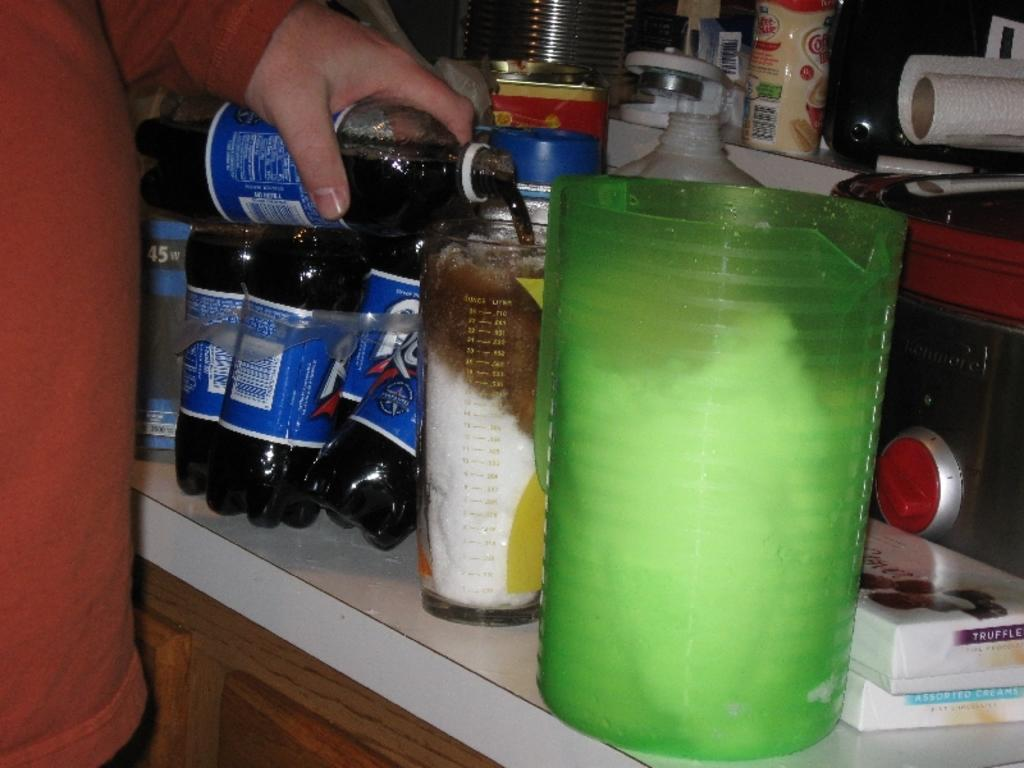What type of objects can be seen on the countertop in the image? There are bottles, a glass, and containers on the countertop in the image. What is the person in the image doing with one of the bottles? One person is holding a bottle in the image. Can you describe the other objects on the countertop? The other objects on the countertop are containers. What type of silk fabric is draped over the bike in the image? There is no bike or silk fabric present in the image. 